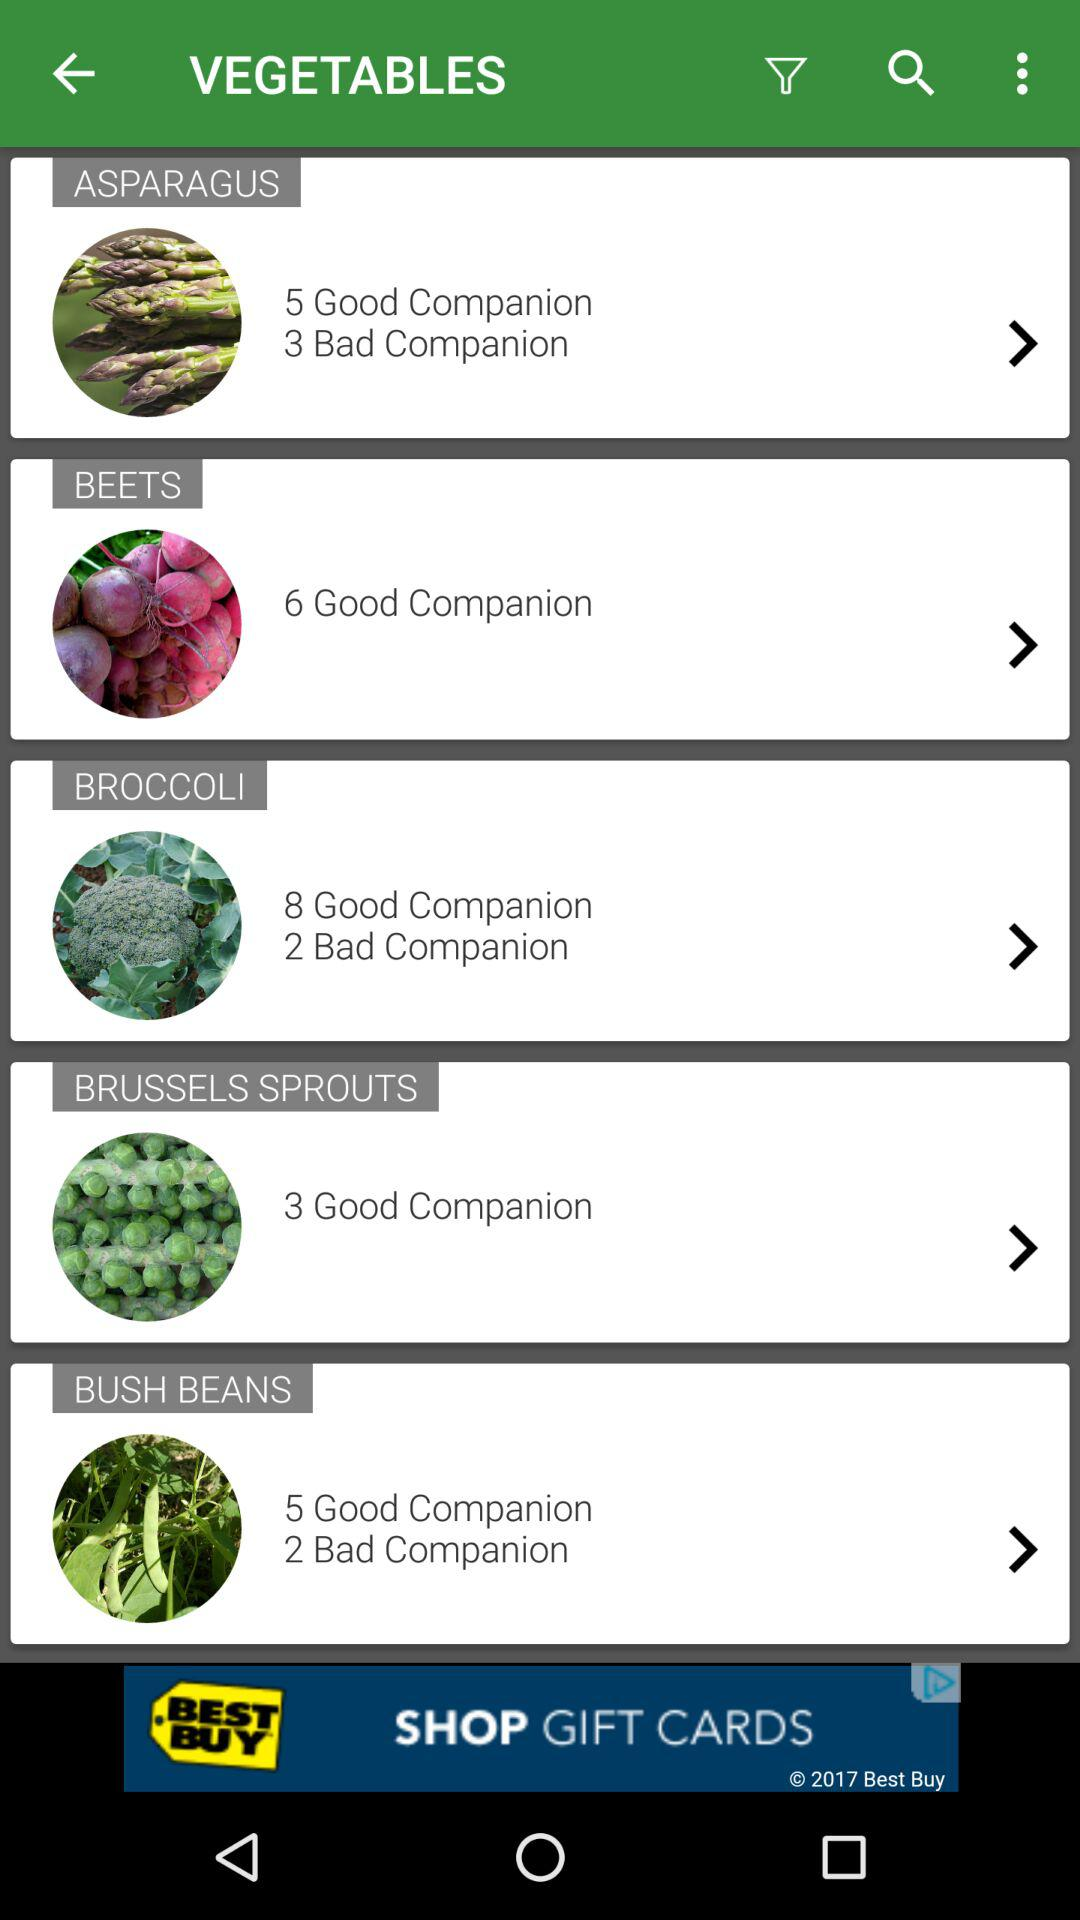How many more good companions does broccoli have than bush beans?
Answer the question using a single word or phrase. 3 